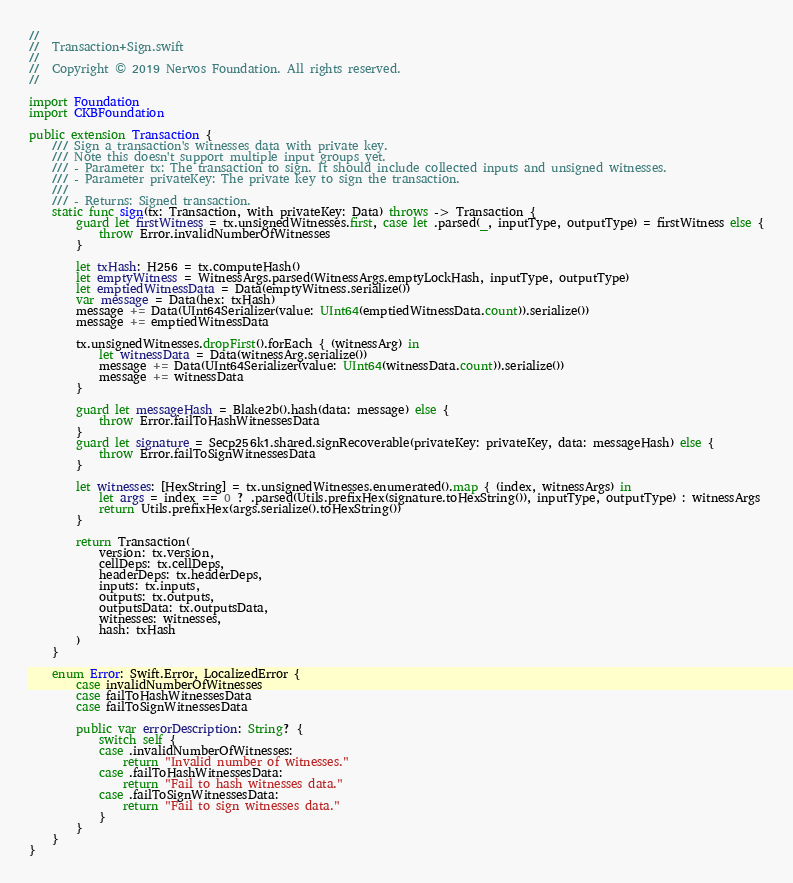<code> <loc_0><loc_0><loc_500><loc_500><_Swift_>//
//  Transaction+Sign.swift
//
//  Copyright © 2019 Nervos Foundation. All rights reserved.
//

import Foundation
import CKBFoundation

public extension Transaction {
    /// Sign a transaction's witnesses data with private key.
    /// Note this doesn't support multiple input groups yet.
    /// - Parameter tx: The transaction to sign. It should include collected inputs and unsigned witnesses.
    /// - Parameter privateKey: The private key to sign the transaction.
    ///
    /// - Returns: Signed transaction.
    static func sign(tx: Transaction, with privateKey: Data) throws -> Transaction {
        guard let firstWitness = tx.unsignedWitnesses.first, case let .parsed(_, inputType, outputType) = firstWitness else {
            throw Error.invalidNumberOfWitnesses
        }

        let txHash: H256 = tx.computeHash()
        let emptyWitness = WitnessArgs.parsed(WitnessArgs.emptyLockHash, inputType, outputType)
        let emptiedWitnessData = Data(emptyWitness.serialize())
        var message = Data(hex: txHash)
        message += Data(UInt64Serializer(value: UInt64(emptiedWitnessData.count)).serialize())
        message += emptiedWitnessData

        tx.unsignedWitnesses.dropFirst().forEach { (witnessArg) in
            let witnessData = Data(witnessArg.serialize())
            message += Data(UInt64Serializer(value: UInt64(witnessData.count)).serialize())
            message += witnessData
        }

        guard let messageHash = Blake2b().hash(data: message) else {
            throw Error.failToHashWitnessesData
        }
        guard let signature = Secp256k1.shared.signRecoverable(privateKey: privateKey, data: messageHash) else {
            throw Error.failToSignWitnessesData
        }

        let witnesses: [HexString] = tx.unsignedWitnesses.enumerated().map { (index, witnessArgs) in
            let args = index == 0 ? .parsed(Utils.prefixHex(signature.toHexString()), inputType, outputType) : witnessArgs
            return Utils.prefixHex(args.serialize().toHexString())
        }

        return Transaction(
            version: tx.version,
            cellDeps: tx.cellDeps,
            headerDeps: tx.headerDeps,
            inputs: tx.inputs,
            outputs: tx.outputs,
            outputsData: tx.outputsData,
            witnesses: witnesses,
            hash: txHash
        )
    }

    enum Error: Swift.Error, LocalizedError {
        case invalidNumberOfWitnesses
        case failToHashWitnessesData
        case failToSignWitnessesData

        public var errorDescription: String? {
            switch self {
            case .invalidNumberOfWitnesses:
                return "Invalid number of witnesses."
            case .failToHashWitnessesData:
                return "Fail to hash witnesses data."
            case .failToSignWitnessesData:
                return "Fail to sign witnesses data."
            }
        }
    }
}
</code> 